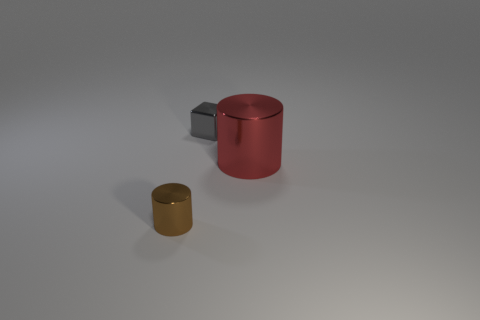Are there any other things that have the same size as the red cylinder?
Your response must be concise. No. Are there any brown shiny cylinders?
Offer a very short reply. Yes. The small shiny object that is behind the brown shiny cylinder is what color?
Provide a succinct answer. Gray. There is a large cylinder; are there any small brown metallic cylinders to the right of it?
Provide a succinct answer. No. Is the number of small blue matte balls greater than the number of large metal cylinders?
Ensure brevity in your answer.  No. What color is the cylinder that is to the left of the metallic cylinder behind the cylinder in front of the big red metal object?
Provide a succinct answer. Brown. There is a small block that is made of the same material as the small brown thing; what is its color?
Make the answer very short. Gray. What number of objects are metal cylinders behind the tiny brown object or tiny blocks that are behind the red thing?
Provide a succinct answer. 2. There is a metallic cylinder that is on the right side of the tiny brown shiny object; is its size the same as the metal cylinder that is on the left side of the small gray thing?
Provide a succinct answer. No. What color is the tiny thing that is the same shape as the large red thing?
Ensure brevity in your answer.  Brown. 